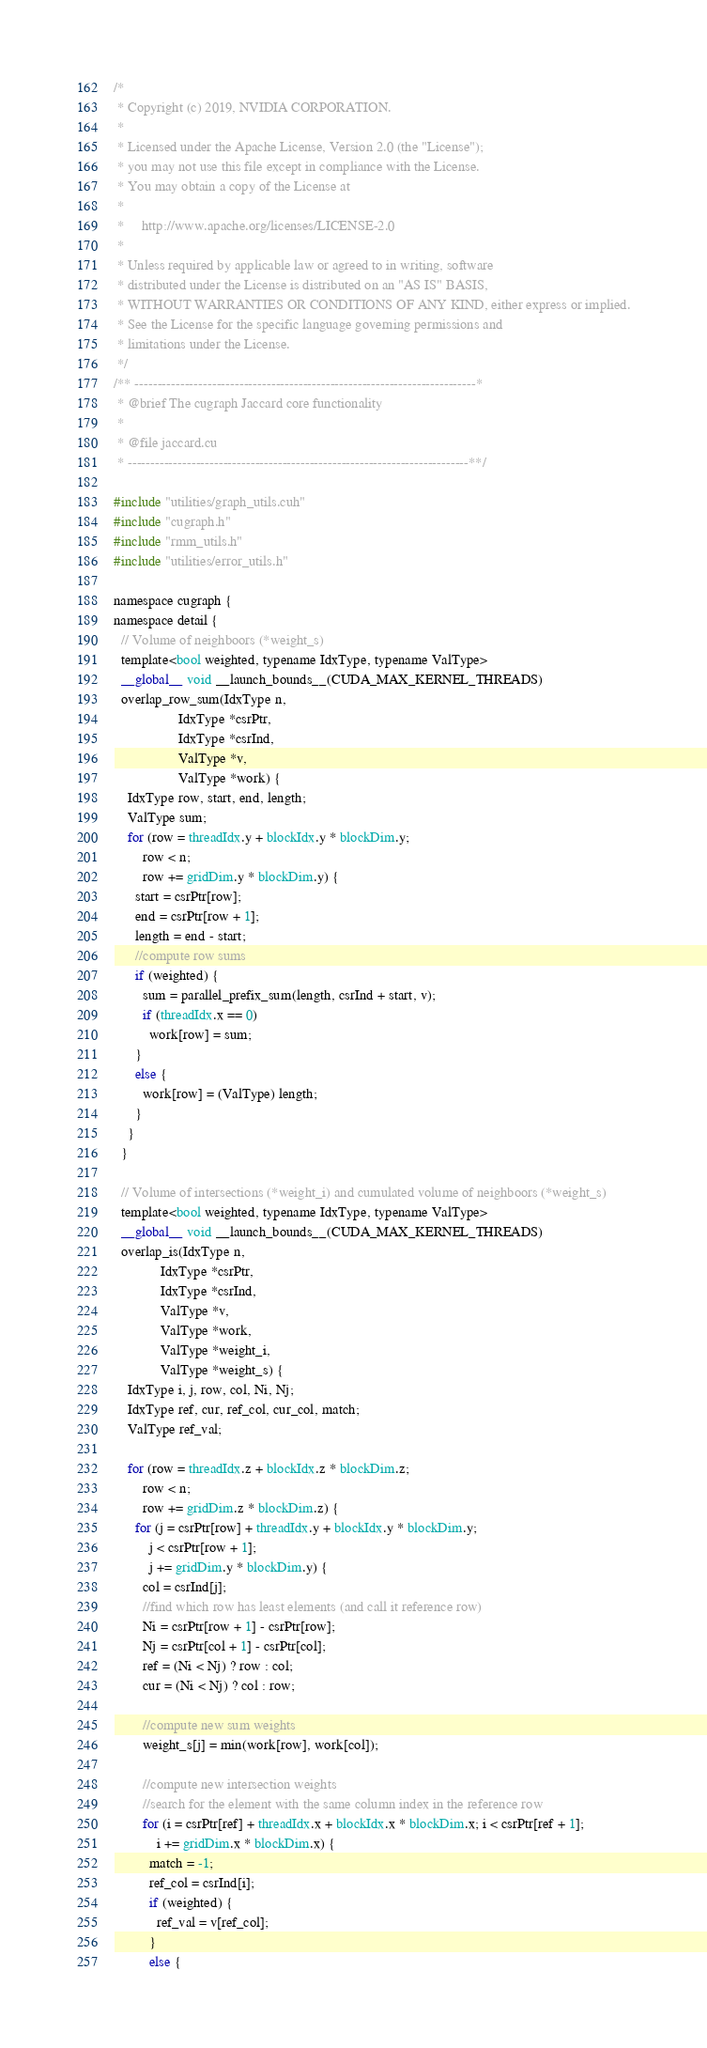Convert code to text. <code><loc_0><loc_0><loc_500><loc_500><_Cuda_>/*
 * Copyright (c) 2019, NVIDIA CORPORATION.
 *
 * Licensed under the Apache License, Version 2.0 (the "License");
 * you may not use this file except in compliance with the License.
 * You may obtain a copy of the License at
 *
 *     http://www.apache.org/licenses/LICENSE-2.0
 *
 * Unless required by applicable law or agreed to in writing, software
 * distributed under the License is distributed on an "AS IS" BASIS,
 * WITHOUT WARRANTIES OR CONDITIONS OF ANY KIND, either express or implied.
 * See the License for the specific language governing permissions and
 * limitations under the License.
 */
/** ---------------------------------------------------------------------------*
 * @brief The cugraph Jaccard core functionality
 *
 * @file jaccard.cu
 * ---------------------------------------------------------------------------**/

#include "utilities/graph_utils.cuh"
#include "cugraph.h"
#include "rmm_utils.h"
#include "utilities/error_utils.h"

namespace cugraph { 
namespace detail {
  // Volume of neighboors (*weight_s)
  template<bool weighted, typename IdxType, typename ValType>
  __global__ void __launch_bounds__(CUDA_MAX_KERNEL_THREADS)
  overlap_row_sum(IdxType n,
                  IdxType *csrPtr,
                  IdxType *csrInd,
                  ValType *v,
                  ValType *work) {
    IdxType row, start, end, length;
    ValType sum;
    for (row = threadIdx.y + blockIdx.y * blockDim.y;
        row < n;
        row += gridDim.y * blockDim.y) {
      start = csrPtr[row];
      end = csrPtr[row + 1];
      length = end - start;
      //compute row sums
      if (weighted) {
        sum = parallel_prefix_sum(length, csrInd + start, v);
        if (threadIdx.x == 0)
          work[row] = sum;
      }
      else {
        work[row] = (ValType) length;
      }
    }
  }

  // Volume of intersections (*weight_i) and cumulated volume of neighboors (*weight_s)
  template<bool weighted, typename IdxType, typename ValType>
  __global__ void __launch_bounds__(CUDA_MAX_KERNEL_THREADS)
  overlap_is(IdxType n,
             IdxType *csrPtr,
             IdxType *csrInd,
             ValType *v,
             ValType *work,
             ValType *weight_i,
             ValType *weight_s) {
    IdxType i, j, row, col, Ni, Nj;
    IdxType ref, cur, ref_col, cur_col, match;
    ValType ref_val;

    for (row = threadIdx.z + blockIdx.z * blockDim.z;
        row < n;
        row += gridDim.z * blockDim.z) {
      for (j = csrPtr[row] + threadIdx.y + blockIdx.y * blockDim.y;
          j < csrPtr[row + 1];
          j += gridDim.y * blockDim.y) {
        col = csrInd[j];
        //find which row has least elements (and call it reference row)
        Ni = csrPtr[row + 1] - csrPtr[row];
        Nj = csrPtr[col + 1] - csrPtr[col];
        ref = (Ni < Nj) ? row : col;
        cur = (Ni < Nj) ? col : row;

        //compute new sum weights
        weight_s[j] = min(work[row], work[col]);

        //compute new intersection weights
        //search for the element with the same column index in the reference row
        for (i = csrPtr[ref] + threadIdx.x + blockIdx.x * blockDim.x; i < csrPtr[ref + 1];
            i += gridDim.x * blockDim.x) {
          match = -1;
          ref_col = csrInd[i];
          if (weighted) {
            ref_val = v[ref_col];
          }
          else {</code> 